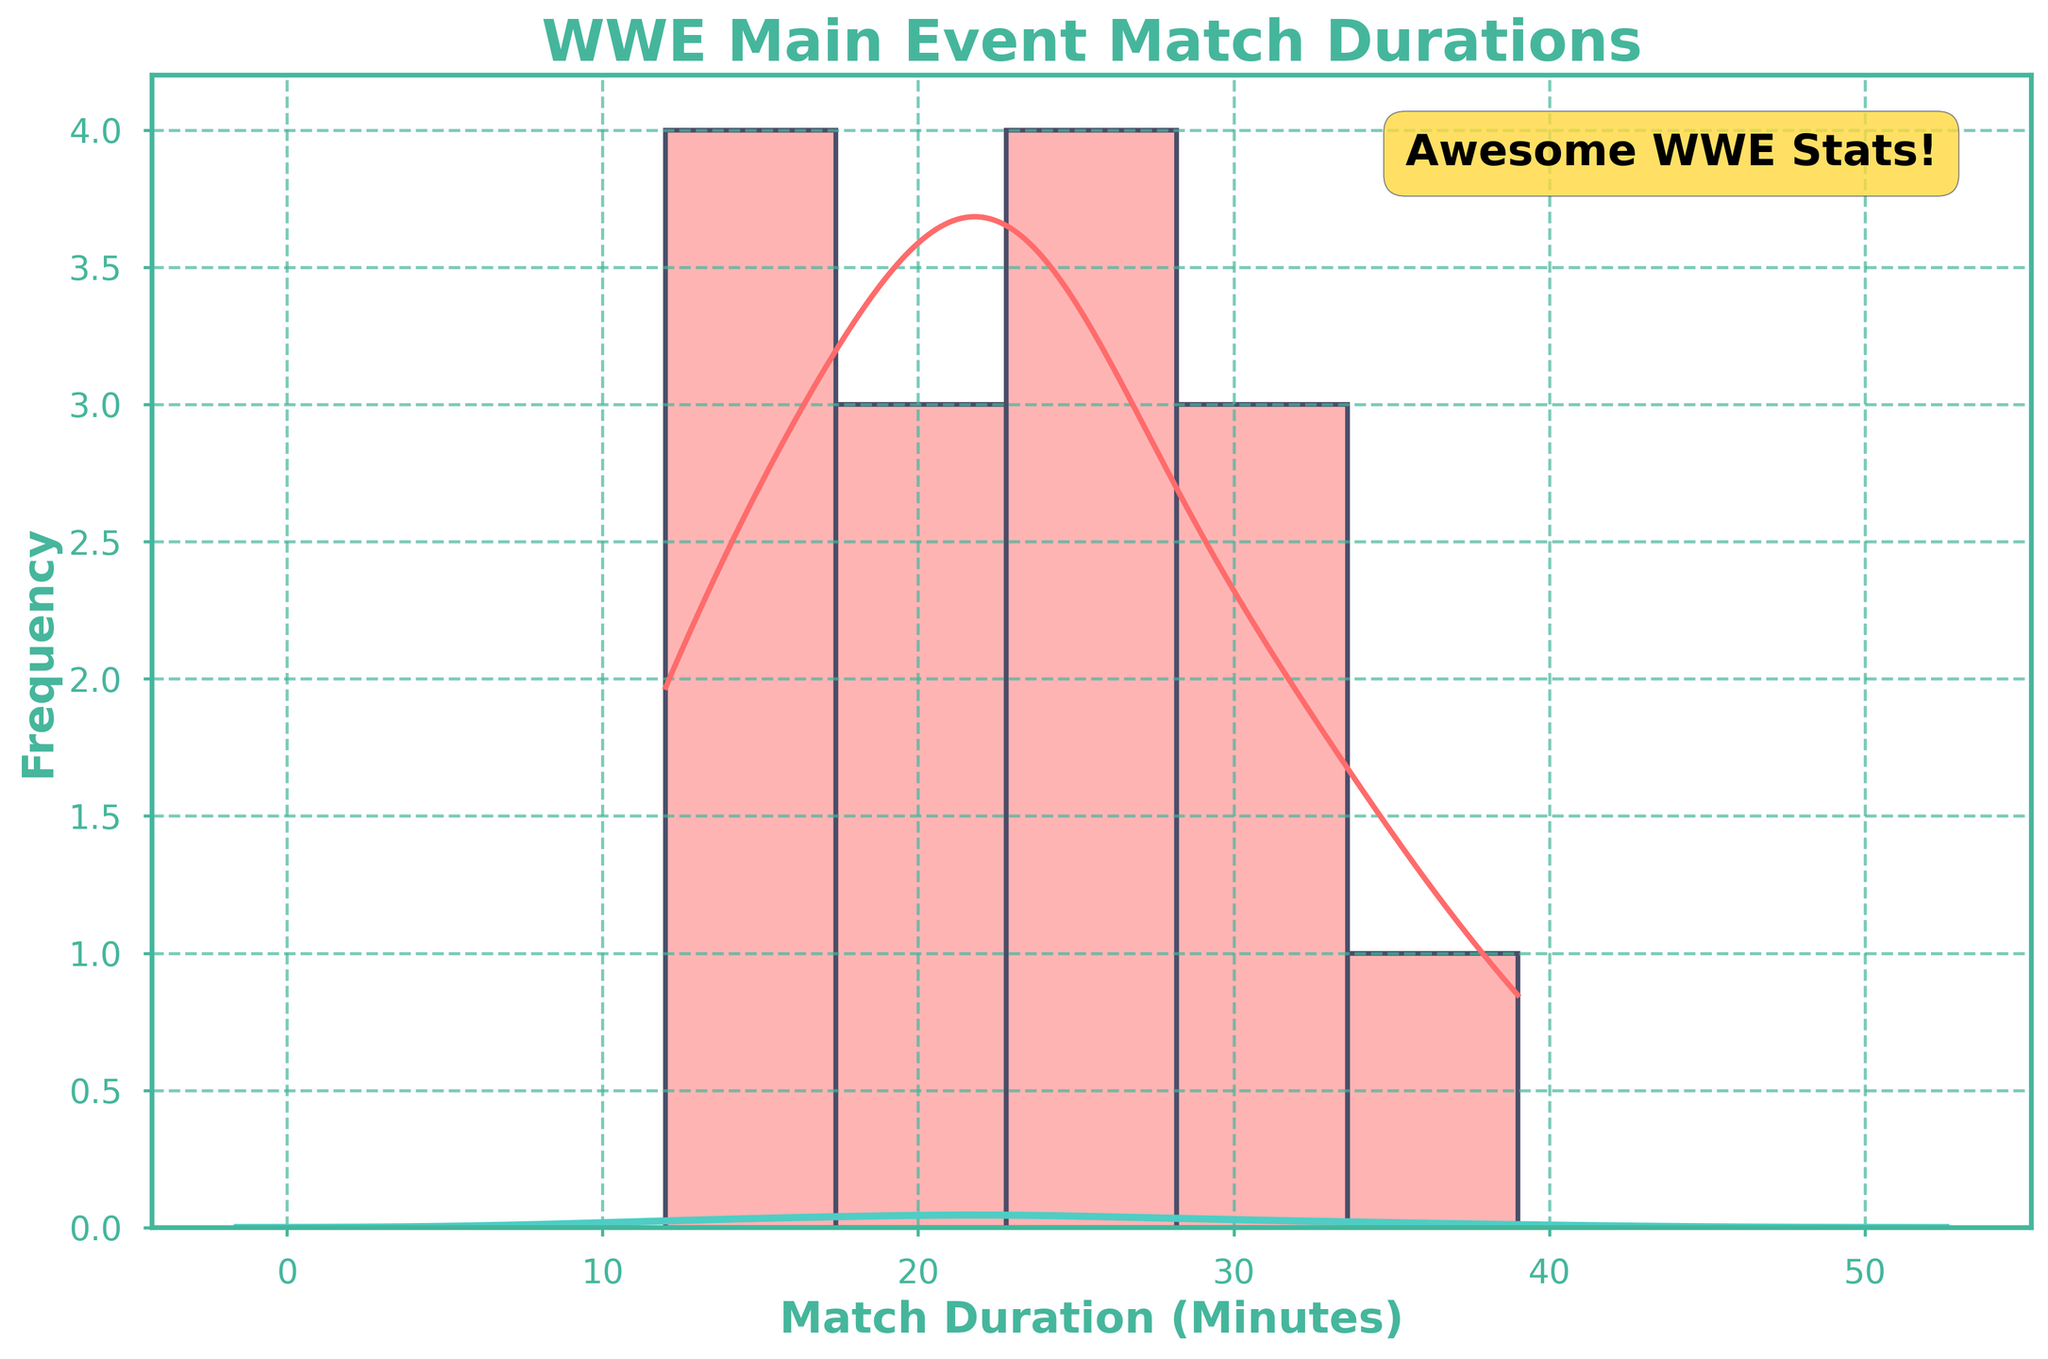What is the title of the figure? The title of the figure is a text element typically placed at the top. It helps viewers understand the main topic of the figure.
Answer: WWE Main Event Match Durations What do the x-axis and y-axis represent? The x-axis usually represents the variable being measured, while the y-axis represents the frequency of this variable within certain ranges. In this case, the x-axis shows the match duration in minutes, and the y-axis shows the frequency of those durations.
Answer: x-axis: Match Duration (Minutes), y-axis: Frequency What are the colors used for the histogram bars and the KDE curve? The colors are visually distinct for easy differentiation. The histogram bars are of one color, and the KDE curve is of another. The histogram bars are red, while the KDE curve is teal.
Answer: Histogram bars: Red, KDE curve: Teal Which match has the longest duration, and how long is it? By identifying the highest bar on the x-axis and checking its corresponding value, we can determine which match has the longest duration. The longest match duration is between 30 and 40 minutes. The highest value in the dataset within this range is from Survivor Series WarGames 2022: The Bloodline vs The Brawling Brutes, which lasted 39 minutes.
Answer: Survivor Series WarGames 2022: The Bloodline vs The Brawling Brutes, 39 minutes What match duration appears the most frequently? The most frequent match duration is represented by the tallest bar in the histogram. The peak of the histogram provides this information.
Answer: Around 23 minutes How many main event matches last 30 minutes or more? To determine this, count the frequency of bars representing match durations greater than or equal to 30 minutes. The histogram shows two matches in this range, from durations 30–40 minutes.
Answer: 2 matches What is the range of match durations shown in the figure? The range can be determined by identifying the minimum and maximum values along the x-axis. The minimum duration is 12 minutes (the start of the histogram data), and the maximum duration is 39 minutes (higher end of the histogram data).
Answer: 12 to 39 minutes How does the frequency of matches around 20 minutes compare to those around 30 minutes? This can be determined by examining the heights of the bars around these durations on the histogram. Matches around 20 minutes have higher frequency than those around 30 minutes.
Answer: More frequent around 20 minutes What is the average match duration for the main events shown in the figure? To calculate the mean, sum all the match duration values and divide by the number of matches. The sum of the durations is 373 minutes divided by 15 matches equals approximately 24.87 minutes.
Answer: 24.87 minutes Is there a trend regarding the evolution of match durations over different events? Checking the histogram and KDE for clustering can indicate trends. Most matches tend to cluster around 20–25 minutes, with occasional longer matches. This suggests a preference for matches lasting about 20–25 minutes, with few longer matches.
Answer: Matches cluster around 20–25 minutes, with few longer matches 